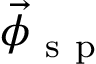<formula> <loc_0><loc_0><loc_500><loc_500>\vec { \phi } _ { s p }</formula> 